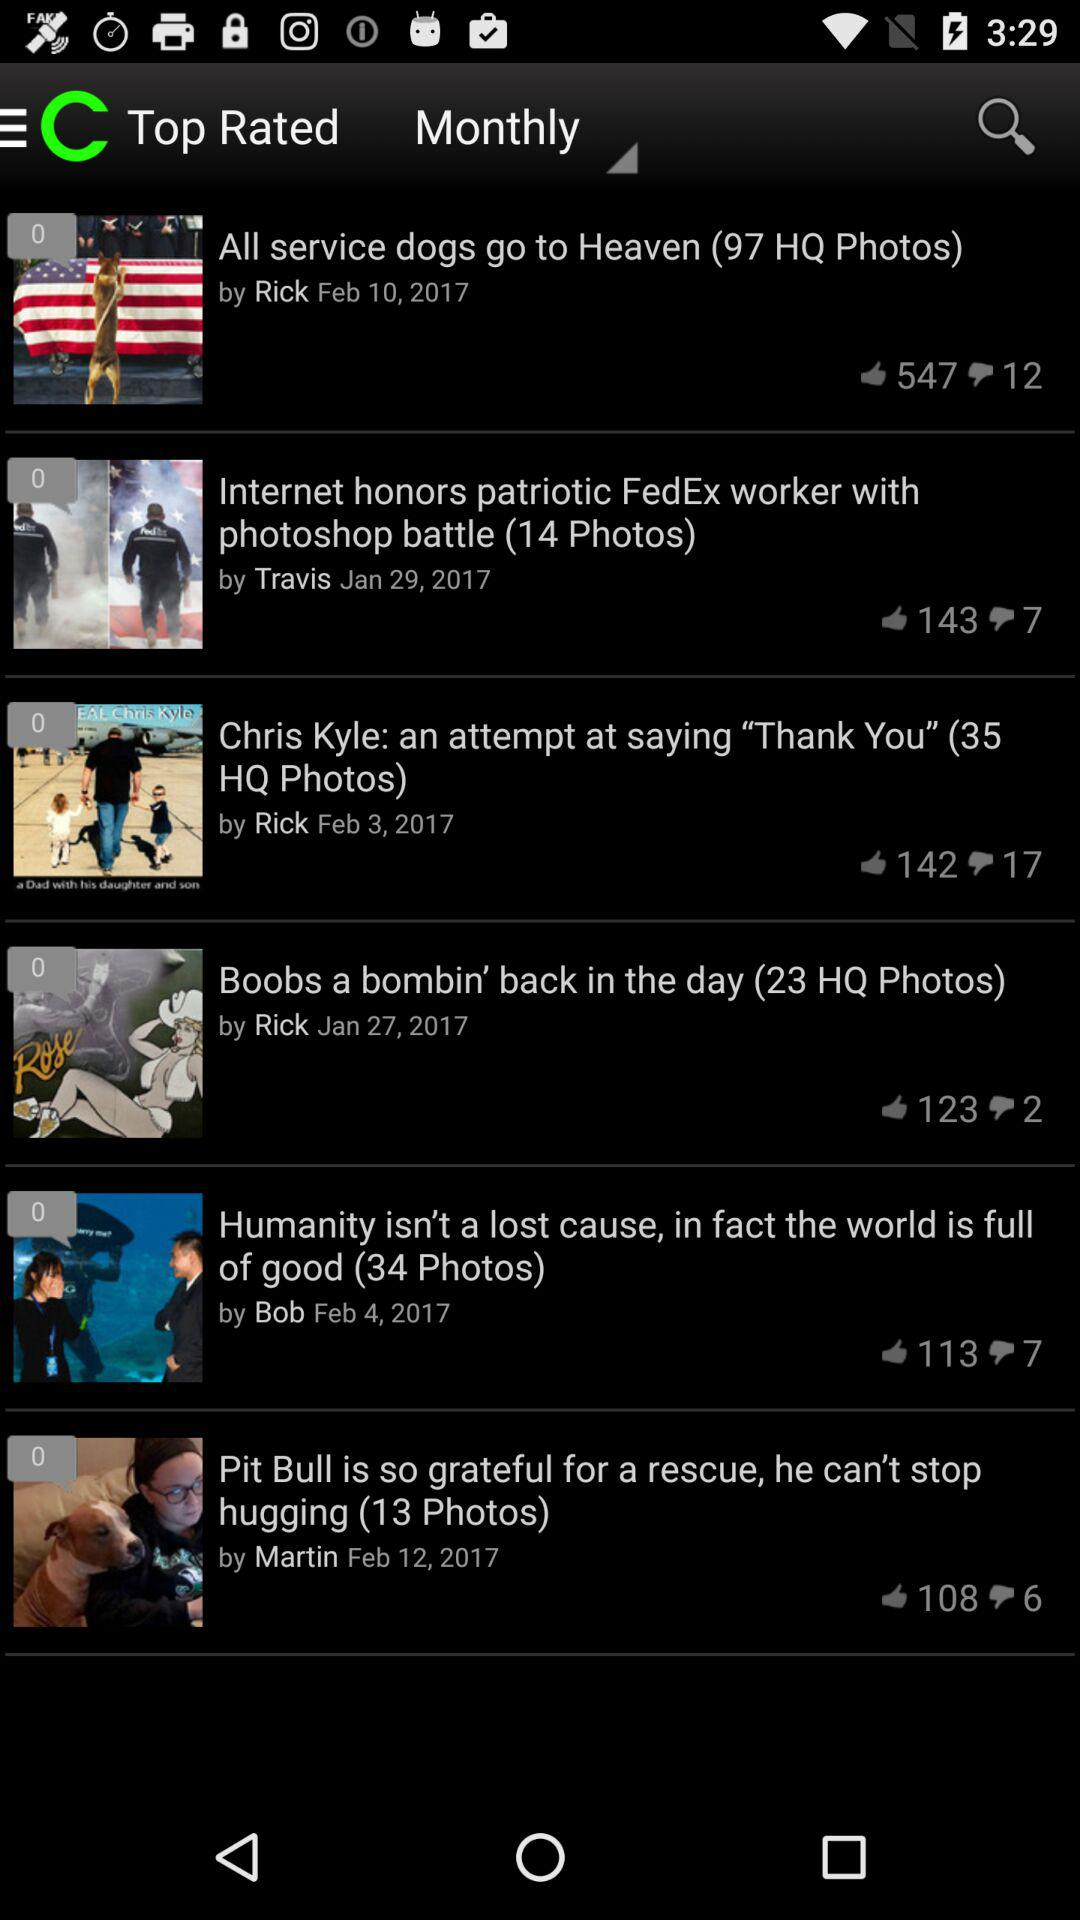Which article has 34 photos? The article, which has 34 photos, is "Humanity isn't a lost cause, in fact the world is full of good". 